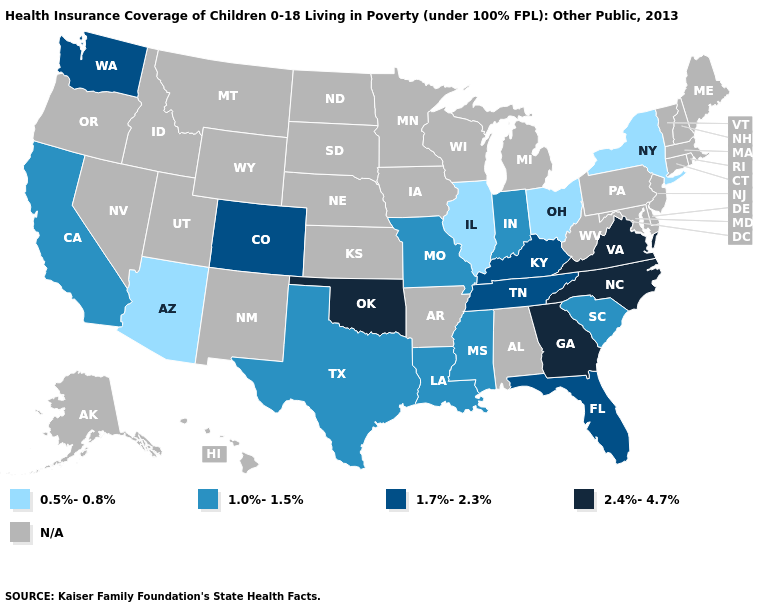What is the highest value in the USA?
Write a very short answer. 2.4%-4.7%. What is the lowest value in the Northeast?
Concise answer only. 0.5%-0.8%. Among the states that border North Carolina , which have the lowest value?
Give a very brief answer. South Carolina. Does North Carolina have the highest value in the USA?
Concise answer only. Yes. Does Virginia have the lowest value in the USA?
Keep it brief. No. What is the highest value in the MidWest ?
Give a very brief answer. 1.0%-1.5%. What is the highest value in the South ?
Quick response, please. 2.4%-4.7%. Does the map have missing data?
Concise answer only. Yes. Name the states that have a value in the range 0.5%-0.8%?
Write a very short answer. Arizona, Illinois, New York, Ohio. What is the lowest value in the West?
Short answer required. 0.5%-0.8%. Which states have the lowest value in the USA?
Keep it brief. Arizona, Illinois, New York, Ohio. What is the value of South Dakota?
Concise answer only. N/A. 